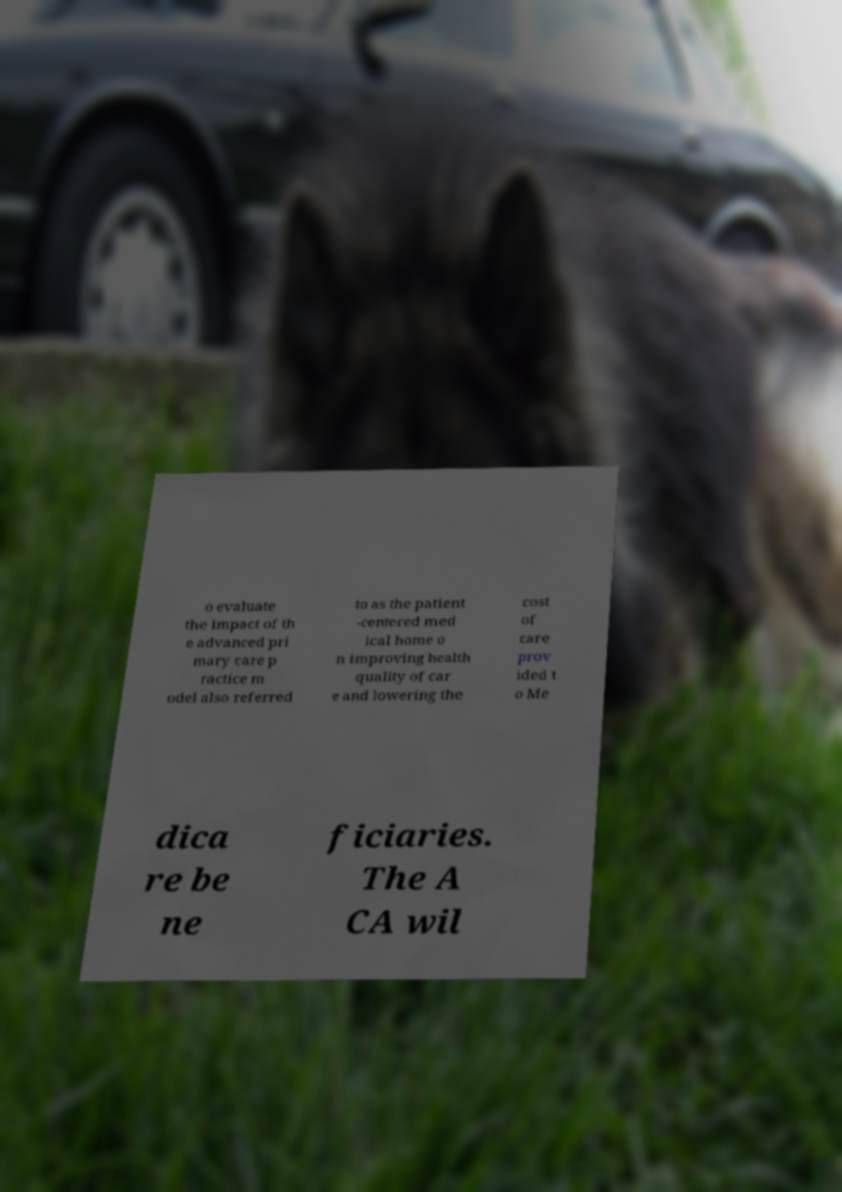There's text embedded in this image that I need extracted. Can you transcribe it verbatim? o evaluate the impact of th e advanced pri mary care p ractice m odel also referred to as the patient -centered med ical home o n improving health quality of car e and lowering the cost of care prov ided t o Me dica re be ne ficiaries. The A CA wil 